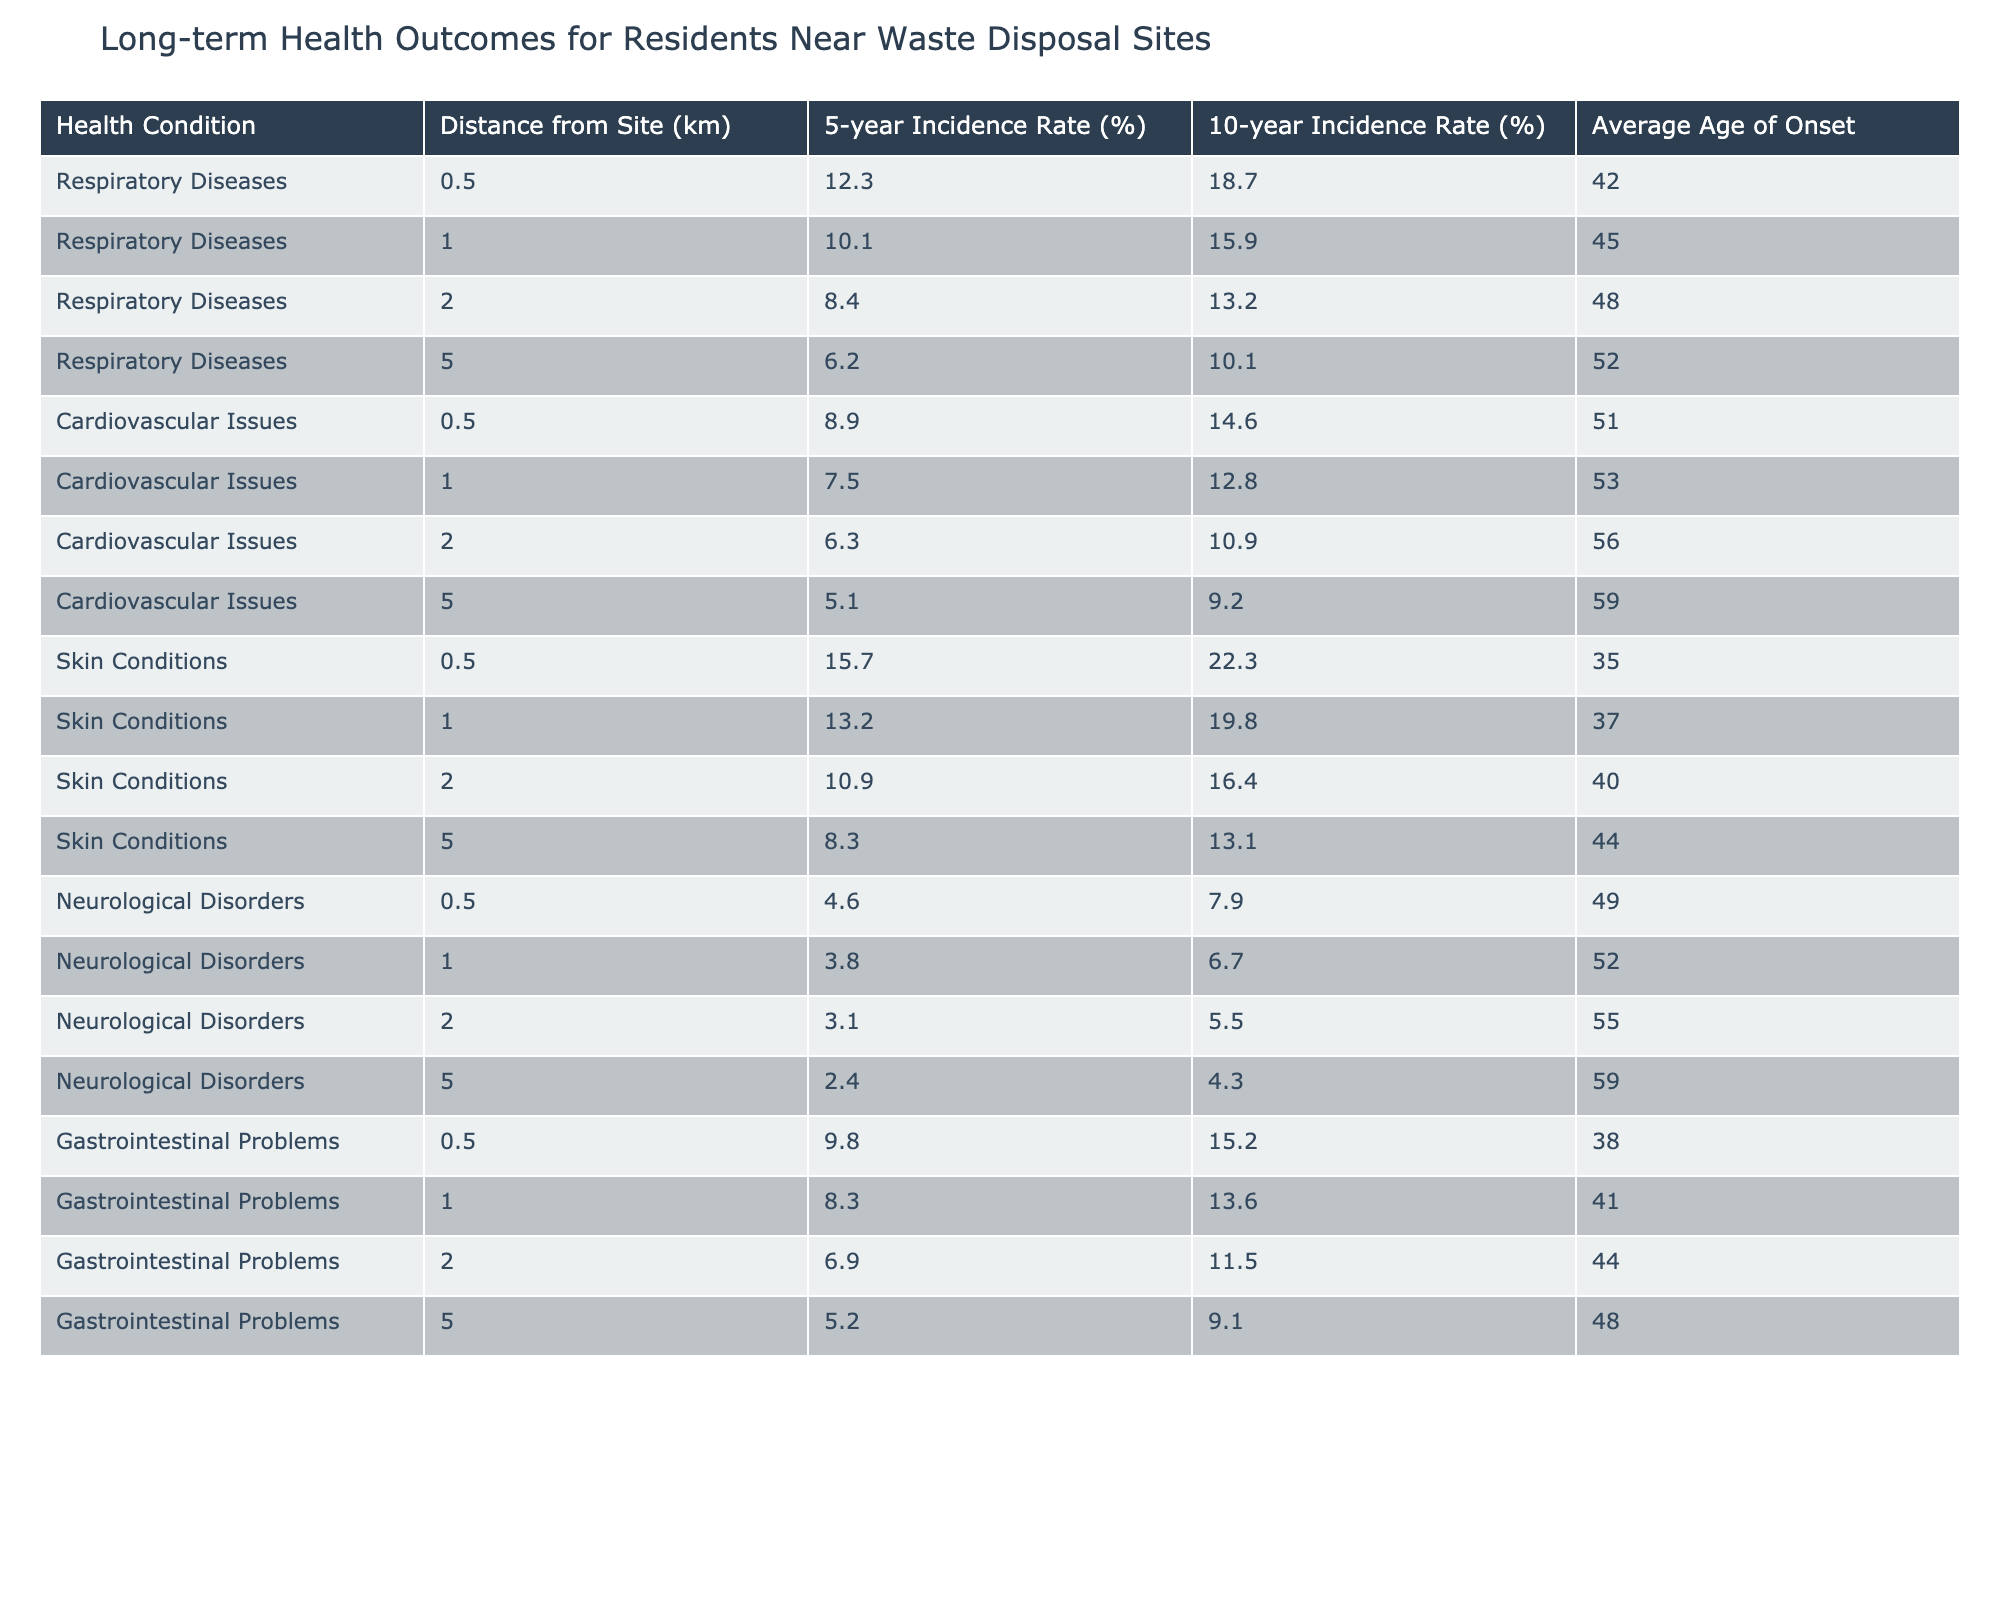What is the 5-year incidence rate of respiratory diseases at 0.5 km? The table shows that the 5-year incidence rate of respiratory diseases at a distance of 0.5 km is 12.3%.
Answer: 12.3% What is the average age of onset for skin conditions within 1 km? According to the table, the average age of onset for skin conditions at 1 km is 37 years.
Answer: 37 Do cardiovascular issues have a higher 10-year incidence rate at 0.5 km compared to respiratory diseases at the same distance? The table indicates that the 10-year incidence rate for cardiovascular issues at 0.5 km is 14.6%, while respiratory diseases have a 10-year incidence rate of 18.7% at the same distance, indicating respiratory diseases have a higher rate.
Answer: Yes What is the difference in the 5-year incidence rates of gastrointestinal problems between 0.5 km and 2 km? The 5-year incidence rate for gastrointestinal problems at 0.5 km is 9.8%, while at 2 km it is 6.9%. The difference is 9.8% - 6.9% = 2.9%.
Answer: 2.9% Which health condition has the highest 10-year incidence rate at a distance of 1 km? The table shows that skin conditions have the highest 10-year incidence rate at 1 km with 19.8%, higher than the rates for respiratory diseases (15.9%) and cardiovascular issues (12.8%).
Answer: Skin Conditions What is the trend in the 5-year incidence rates of respiratory diseases as the distance from the waste disposal site increases? Observing the table, we see that the 5-year incidence rates for respiratory diseases decrease as the distance increases: 12.3% at 0.5 km, 10.1% at 1 km, 8.4% at 2 km, and 6.2% at 5 km. This indicates a negative correlation between distance and 5-year incidence rate for respiratory diseases.
Answer: Decreases Are neurological disorders more common than gastrointestinal problems at a distance of 0.5 km? The table shows the 5-year incidence rate for neurological disorders at 0.5 km is 4.6%, while for gastrointestinal problems it is 9.8%. Thus, neurological disorders are less common at this distance.
Answer: No What is the average of the 10-year incidence rates for skin conditions at distances of 0.5 km and 1 km? The 10-year incidence rate for skin conditions at 0.5 km is 22.3%, and at 1 km it is 19.8%. To find the average, we sum these values (22.3 + 19.8 = 42.1) and divide by 2, resulting in 42.1 / 2 = 21.05%.
Answer: 21.05% What is the lowest average age of onset for respiratory diseases in the table? The table shows that the average age of onset for respiratory diseases at 0.5 km is 42, at 1 km is 45, at 2 km is 48, and at 5 km is 52. The lowest average age is therefore 42 years at 0.5 km.
Answer: 42 What percentage of residents experience skin conditions when living 5 km away from the waste site? The table indicates that the 10-year incidence rate for skin conditions at 5 km is 13.1%. This means 13.1% of residents experience skin conditions at this distance.
Answer: 13.1% Is there a consistent pattern in the incidence rates for all health conditions as the distance increases from the waste disposal site? The table demonstrates a consistent trend across all health conditions where the incidence rates tend to decrease as the distance from the waste disposal site increases.
Answer: Yes 